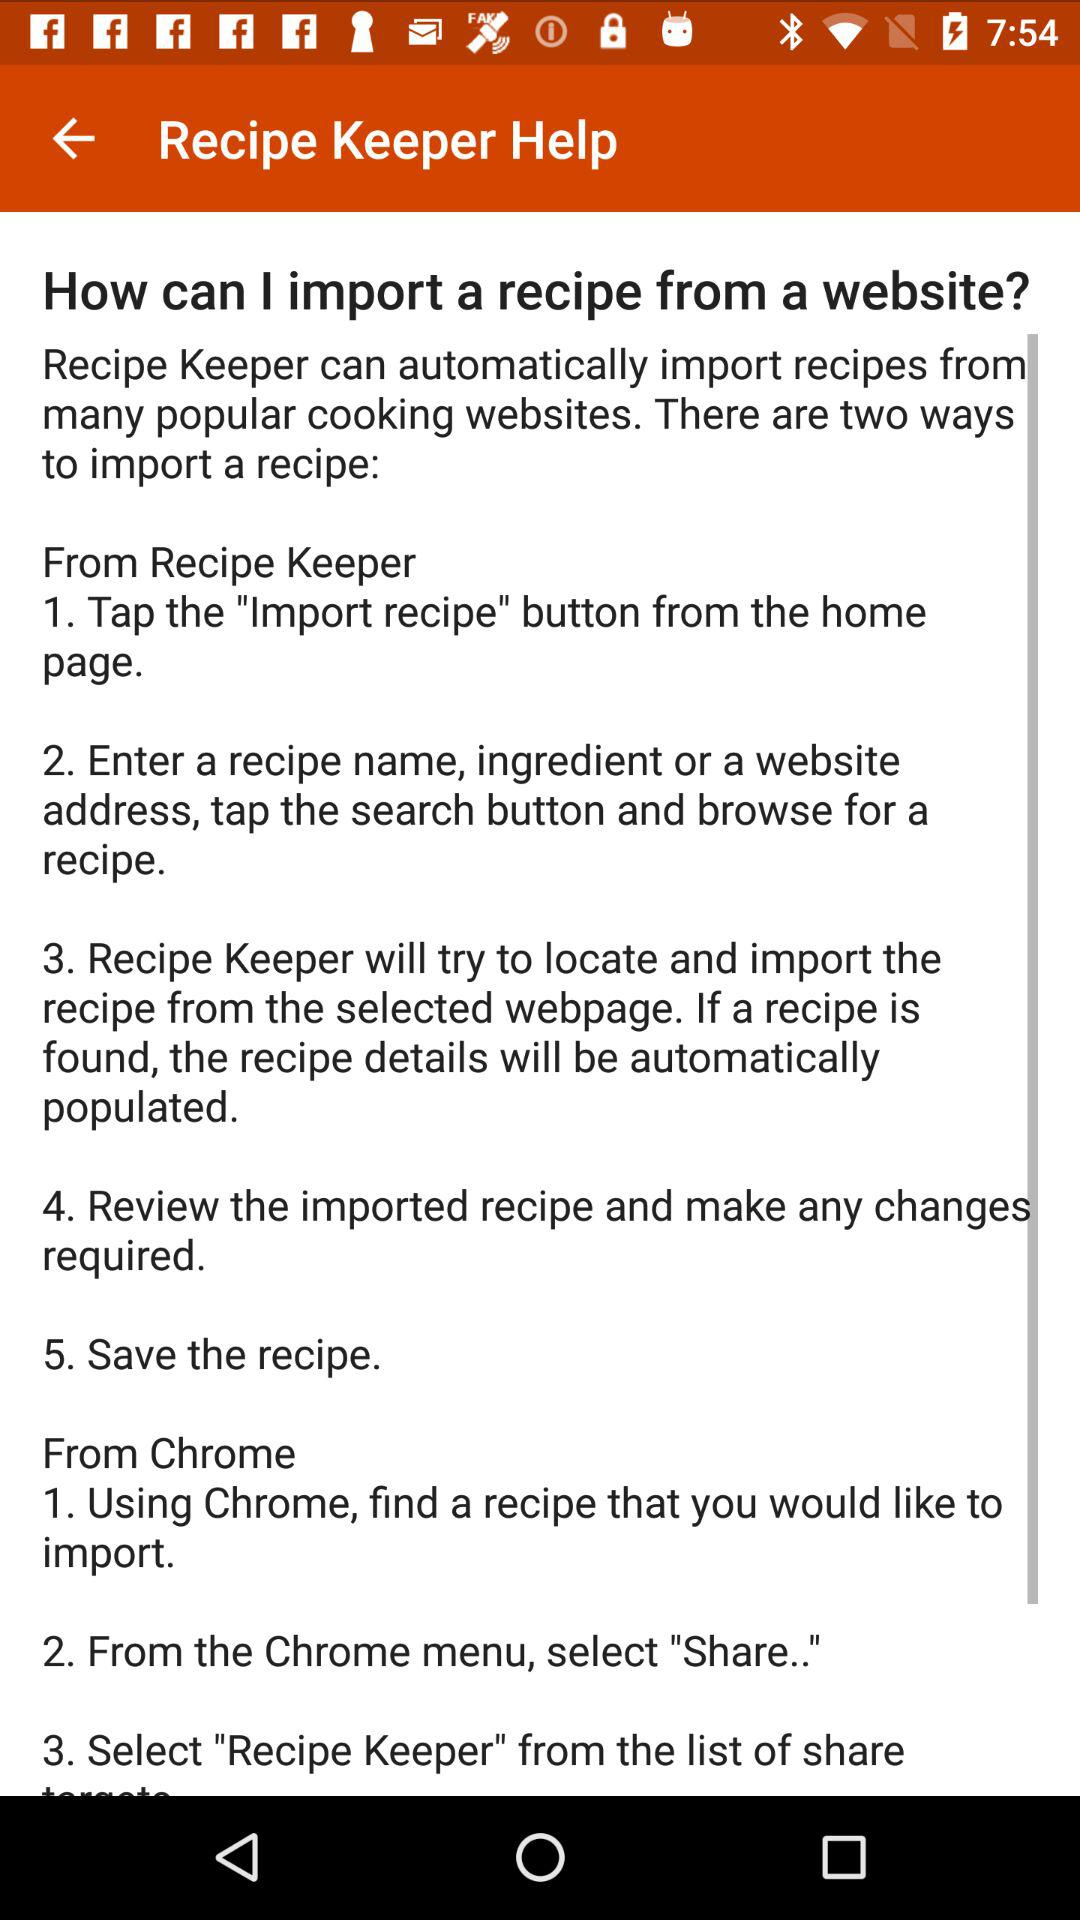How many steps are there in the import recipe process from Chrome?
Answer the question using a single word or phrase. 3 